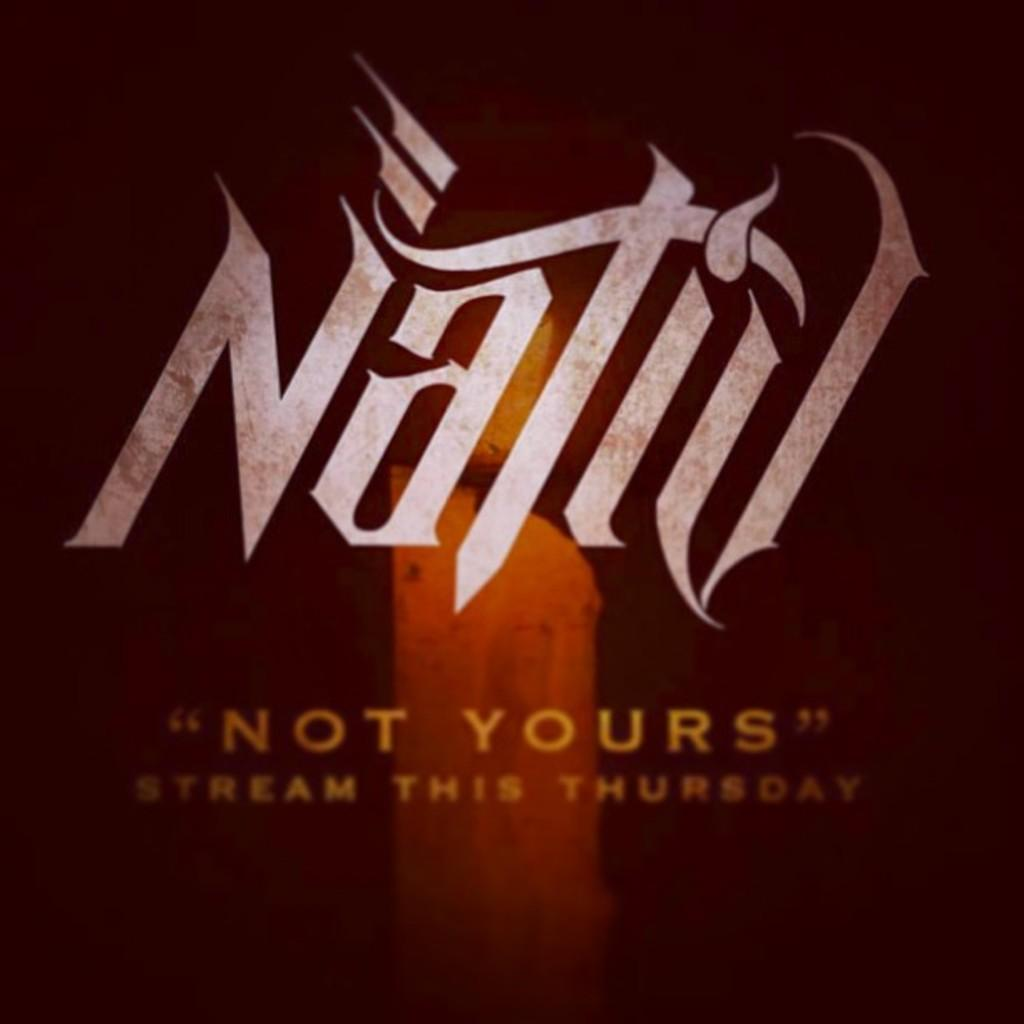Provide a one-sentence caption for the provided image. An ad for a candle brand Natid that say ""not yours" stream this Thursday.". 